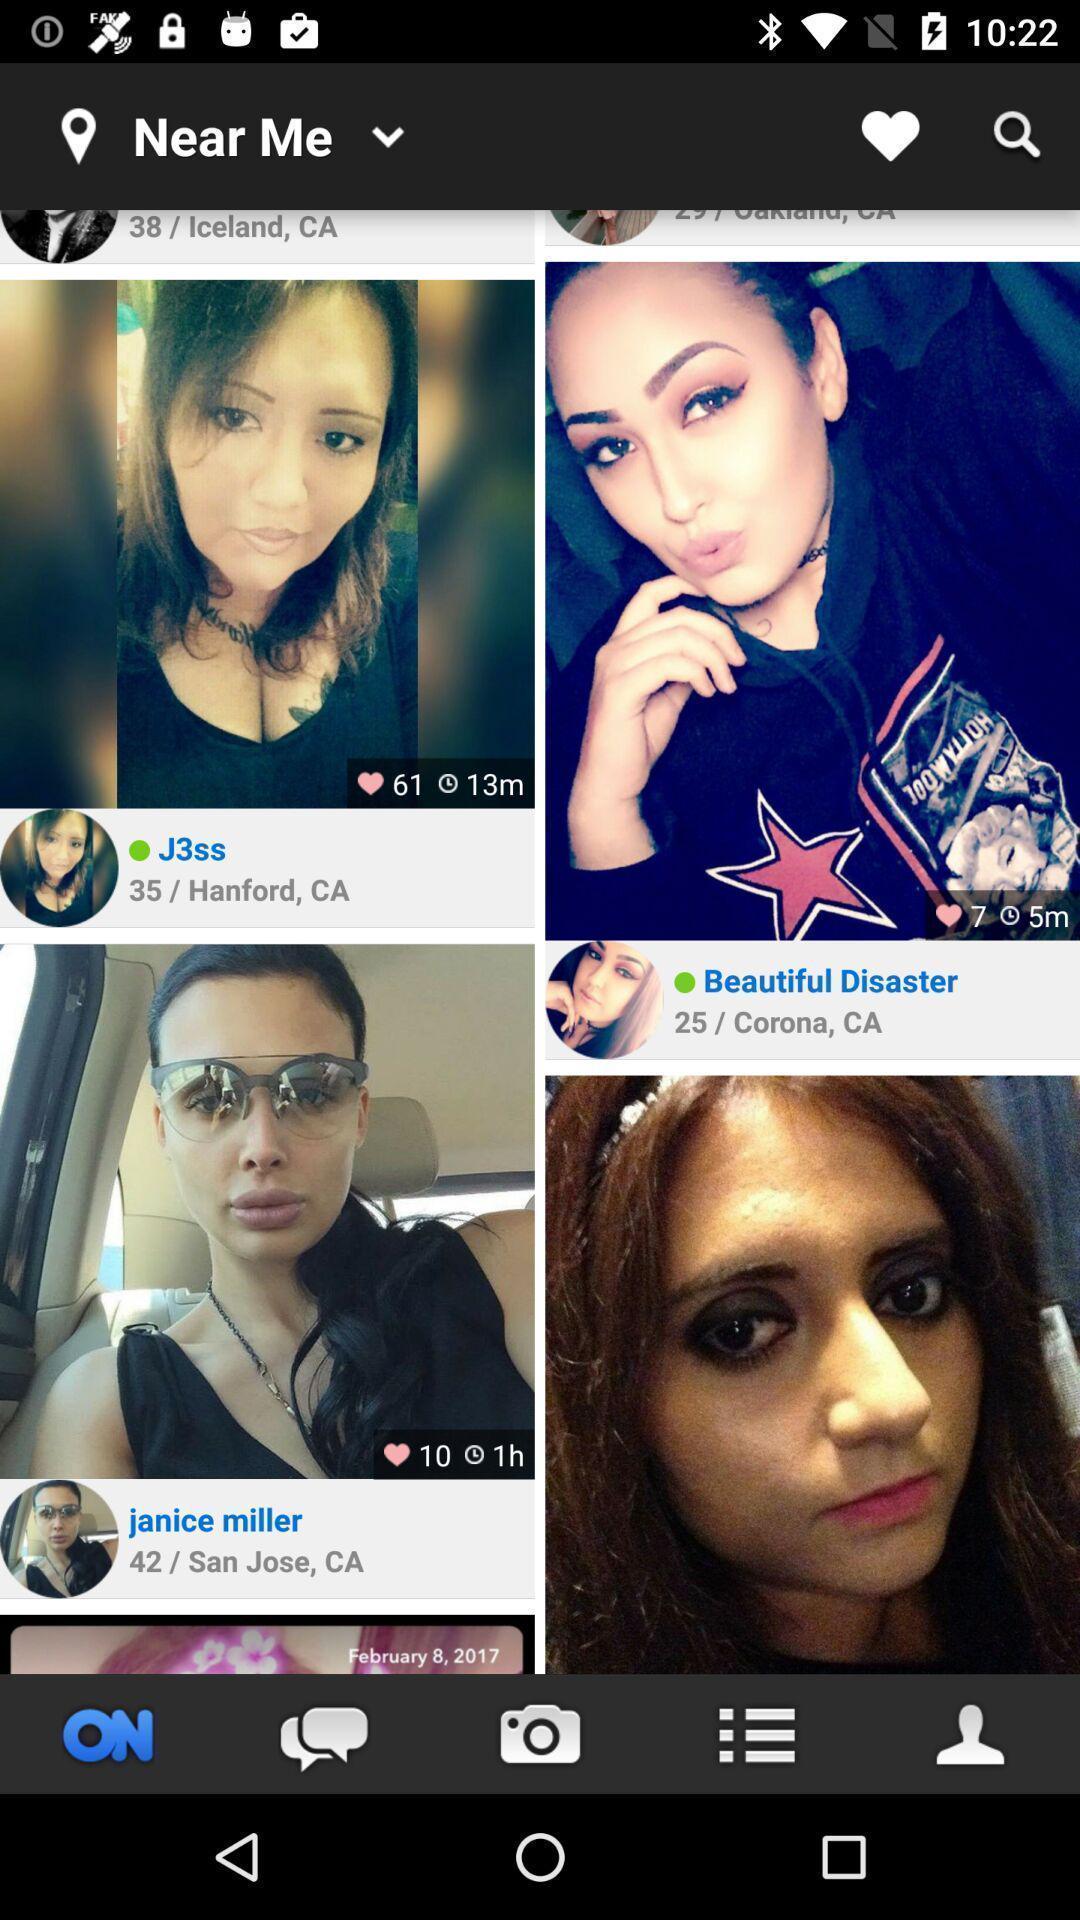Summarize the information in this screenshot. Page showing profiles in a social app. 